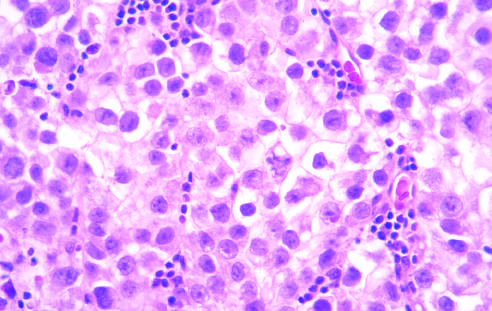what reveals large cells with distinct cell borders, pale nuclei, prominent nucleoli, and a sparse lymphocytic infiltrate?
Answer the question using a single word or phrase. Microscopic examination 